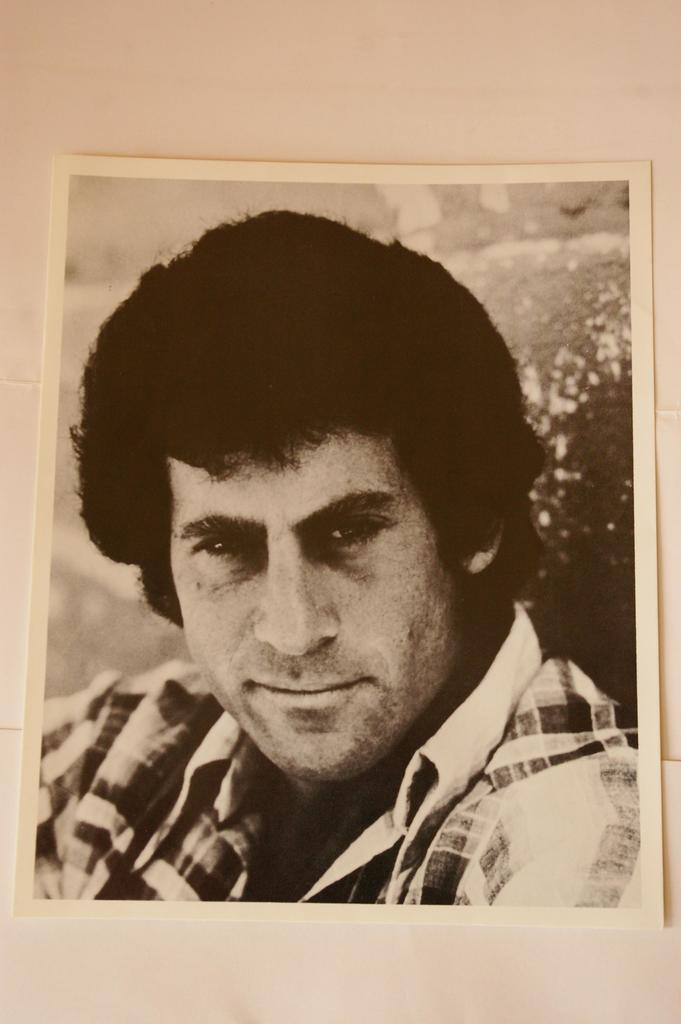What is the main subject of the image? There is a photo of a person in the image. Where is the photo located? The photo is placed on a table. How much money is the person holding in the photo? There is no indication of money in the photo, as it only shows a person. What type of writing instrument is the person using in the photo? There is no writing instrument visible in the photo, as it only shows a person. 